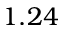<formula> <loc_0><loc_0><loc_500><loc_500>1 . 2 4</formula> 